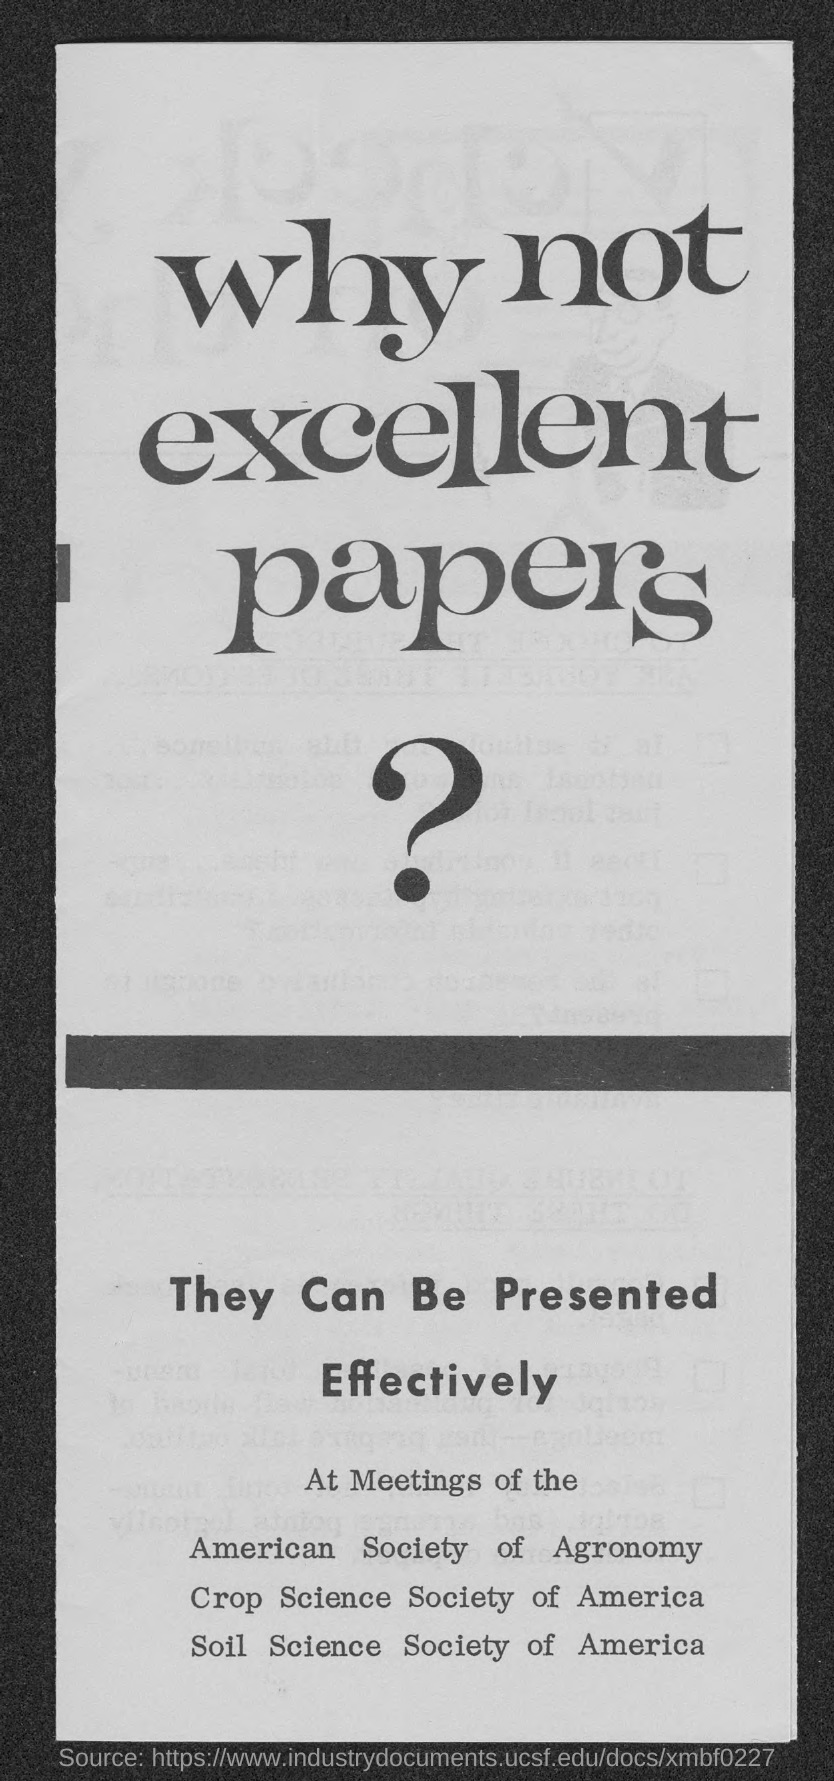Give some essential details in this illustration. The second title in the document is 'They can be Presented Effectively.' The first title in the document is 'Why Not Excellent Papers?' 